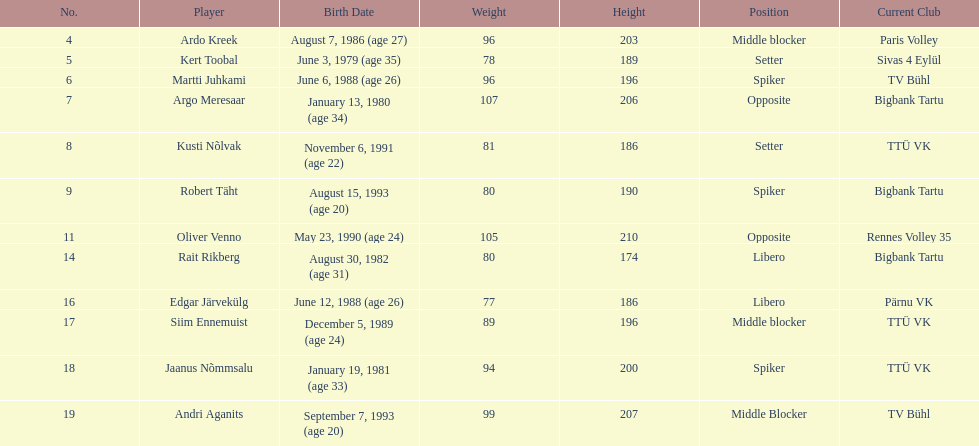Who is the tallest member of estonia's men's national volleyball team? Oliver Venno. 